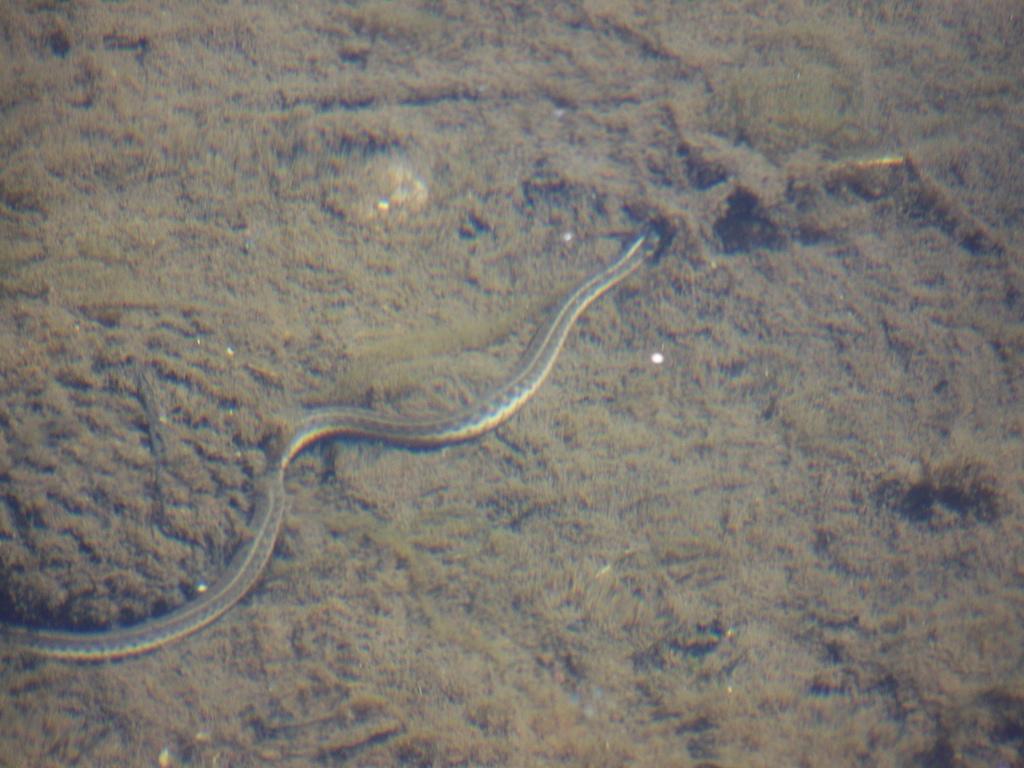Could you give a brief overview of what you see in this image? In this image there is a snake on the ground. 